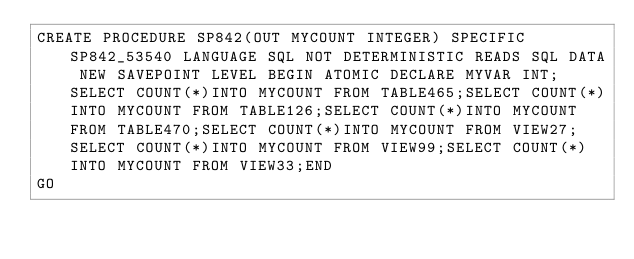Convert code to text. <code><loc_0><loc_0><loc_500><loc_500><_SQL_>CREATE PROCEDURE SP842(OUT MYCOUNT INTEGER) SPECIFIC SP842_53540 LANGUAGE SQL NOT DETERMINISTIC READS SQL DATA NEW SAVEPOINT LEVEL BEGIN ATOMIC DECLARE MYVAR INT;SELECT COUNT(*)INTO MYCOUNT FROM TABLE465;SELECT COUNT(*)INTO MYCOUNT FROM TABLE126;SELECT COUNT(*)INTO MYCOUNT FROM TABLE470;SELECT COUNT(*)INTO MYCOUNT FROM VIEW27;SELECT COUNT(*)INTO MYCOUNT FROM VIEW99;SELECT COUNT(*)INTO MYCOUNT FROM VIEW33;END
GO</code> 